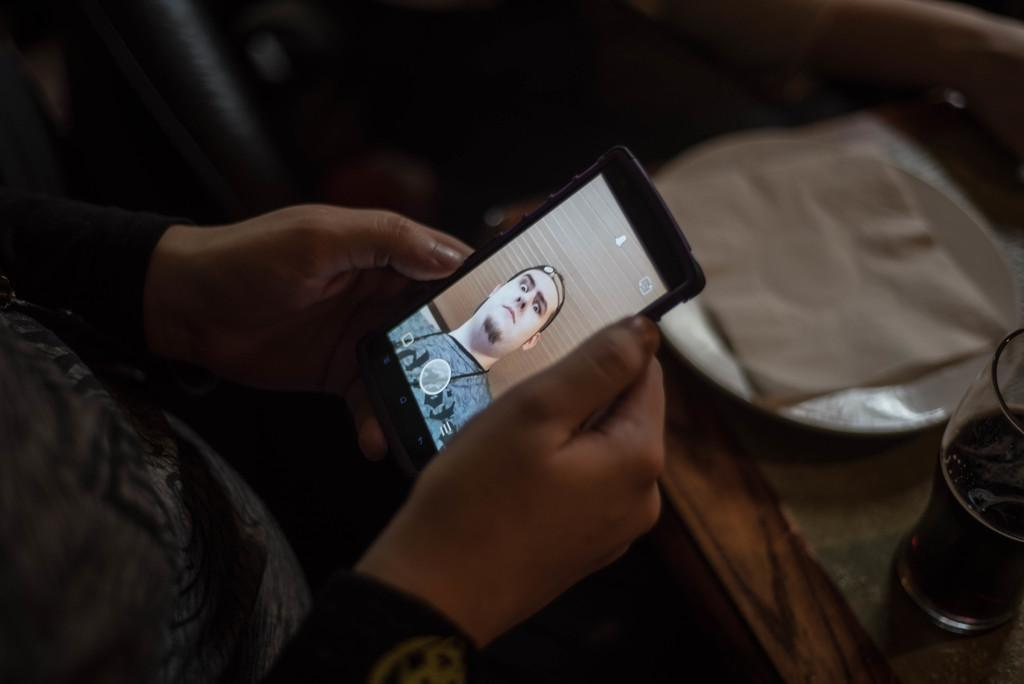What is the person in the image doing? The person in the image is holding a phone. What objects are on the table in the image? There is a glass, a plate, and tissue paper on the table in the image. Can you describe the person's activity in more detail? The person is likely using the phone, as they are holding it. What type of honey can be seen dripping from the wood in the image? There is no honey or wood present in the image. 